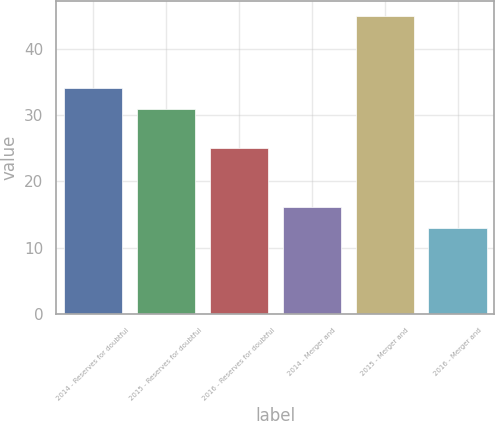<chart> <loc_0><loc_0><loc_500><loc_500><bar_chart><fcel>2014 - Reserves for doubtful<fcel>2015 - Reserves for doubtful<fcel>2016 - Reserves for doubtful<fcel>2014 - Merger and<fcel>2015 - Merger and<fcel>2016 - Merger and<nl><fcel>34.2<fcel>31<fcel>25<fcel>16.2<fcel>45<fcel>13<nl></chart> 